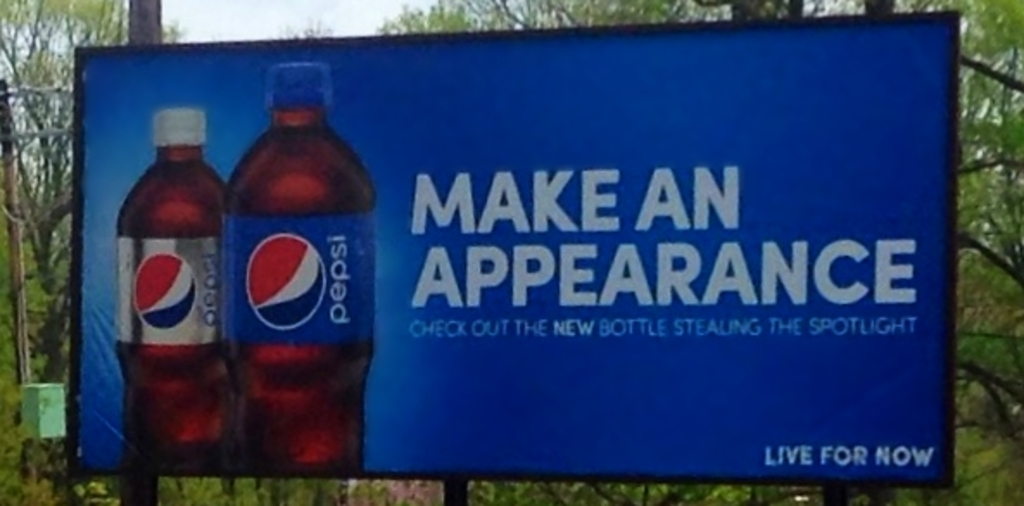How does the phrase 'Make an appearance' relate to the concept of the new bottle design? The phrase 'Make an appearance' cleverly ties into the launch of the new bottle design by implying that the new bottle is not just a product but a statement piece. It suggests that choosing this redesigned Pepsi bottle can similarly allow consumers to 'make an appearance' or stand out in social contexts, much like the new design does amidst traditional beverage options. Does this imply the new design will impact consumer behavior? Absolutely, the emphasis on the new design being able to 'steal the spotlight' indicates Pepsi's strategy to make the bottle visually appealing and modern, potentially influencing consumer behavior by attracting a younger demographic or those interested in premium packaging that reflects their personal style. 